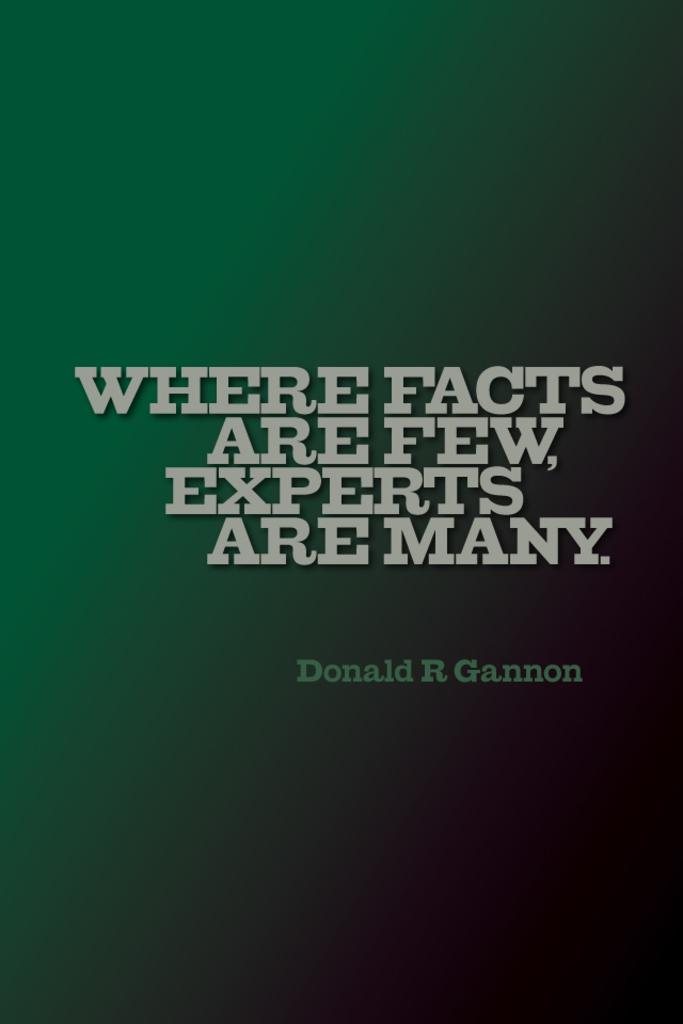Provide a one-sentence caption for the provided image. "Where facts are few, experts are many" and Donald R. Gannon are on a green to black gradient background. 